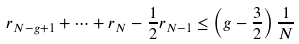<formula> <loc_0><loc_0><loc_500><loc_500>r _ { N - g + 1 } + \cdots + r _ { N } - \frac { 1 } { 2 } r _ { N - 1 } \leq \left ( g - \frac { 3 } { 2 } \right ) \frac { 1 } { N }</formula> 